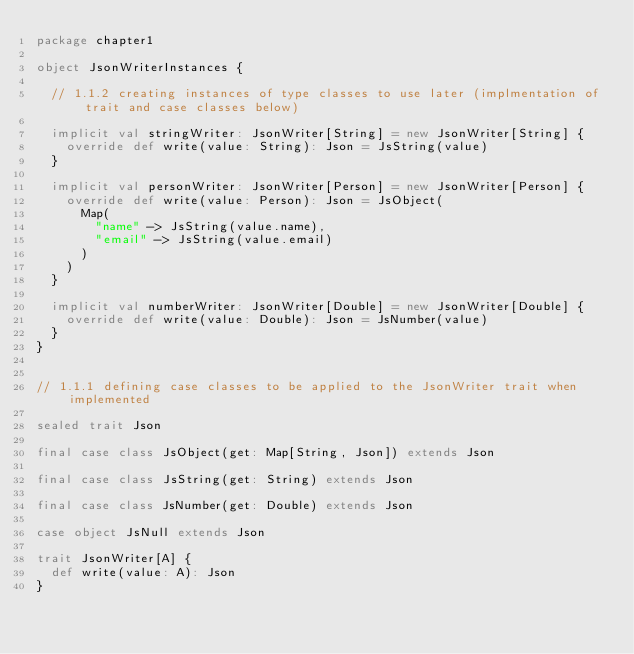<code> <loc_0><loc_0><loc_500><loc_500><_Scala_>package chapter1

object JsonWriterInstances {

  // 1.1.2 creating instances of type classes to use later (implmentation of trait and case classes below)

  implicit val stringWriter: JsonWriter[String] = new JsonWriter[String] {
    override def write(value: String): Json = JsString(value)
  }

  implicit val personWriter: JsonWriter[Person] = new JsonWriter[Person] {
    override def write(value: Person): Json = JsObject(
      Map(
        "name" -> JsString(value.name),
        "email" -> JsString(value.email)
      )
    )
  }

  implicit val numberWriter: JsonWriter[Double] = new JsonWriter[Double] {
    override def write(value: Double): Json = JsNumber(value)
  }
}


// 1.1.1 defining case classes to be applied to the JsonWriter trait when implemented

sealed trait Json

final case class JsObject(get: Map[String, Json]) extends Json

final case class JsString(get: String) extends Json

final case class JsNumber(get: Double) extends Json

case object JsNull extends Json

trait JsonWriter[A] {
  def write(value: A): Json
}
</code> 